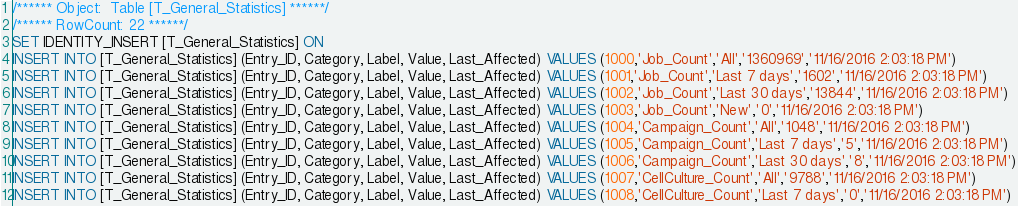Convert code to text. <code><loc_0><loc_0><loc_500><loc_500><_SQL_>/****** Object:  Table [T_General_Statistics] ******/
/****** RowCount: 22 ******/
SET IDENTITY_INSERT [T_General_Statistics] ON
INSERT INTO [T_General_Statistics] (Entry_ID, Category, Label, Value, Last_Affected) VALUES (1000,'Job_Count','All','1360969','11/16/2016 2:03:18 PM')
INSERT INTO [T_General_Statistics] (Entry_ID, Category, Label, Value, Last_Affected) VALUES (1001,'Job_Count','Last 7 days','1602','11/16/2016 2:03:18 PM')
INSERT INTO [T_General_Statistics] (Entry_ID, Category, Label, Value, Last_Affected) VALUES (1002,'Job_Count','Last 30 days','13844','11/16/2016 2:03:18 PM')
INSERT INTO [T_General_Statistics] (Entry_ID, Category, Label, Value, Last_Affected) VALUES (1003,'Job_Count','New','0','11/16/2016 2:03:18 PM')
INSERT INTO [T_General_Statistics] (Entry_ID, Category, Label, Value, Last_Affected) VALUES (1004,'Campaign_Count','All','1048','11/16/2016 2:03:18 PM')
INSERT INTO [T_General_Statistics] (Entry_ID, Category, Label, Value, Last_Affected) VALUES (1005,'Campaign_Count','Last 7 days','5','11/16/2016 2:03:18 PM')
INSERT INTO [T_General_Statistics] (Entry_ID, Category, Label, Value, Last_Affected) VALUES (1006,'Campaign_Count','Last 30 days','8','11/16/2016 2:03:18 PM')
INSERT INTO [T_General_Statistics] (Entry_ID, Category, Label, Value, Last_Affected) VALUES (1007,'CellCulture_Count','All','9788','11/16/2016 2:03:18 PM')
INSERT INTO [T_General_Statistics] (Entry_ID, Category, Label, Value, Last_Affected) VALUES (1008,'CellCulture_Count','Last 7 days','0','11/16/2016 2:03:18 PM')</code> 